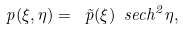Convert formula to latex. <formula><loc_0><loc_0><loc_500><loc_500>p ( \xi , \eta ) = \ \tilde { p } ( \xi ) \ s e c h ^ { 2 } \eta ,</formula> 